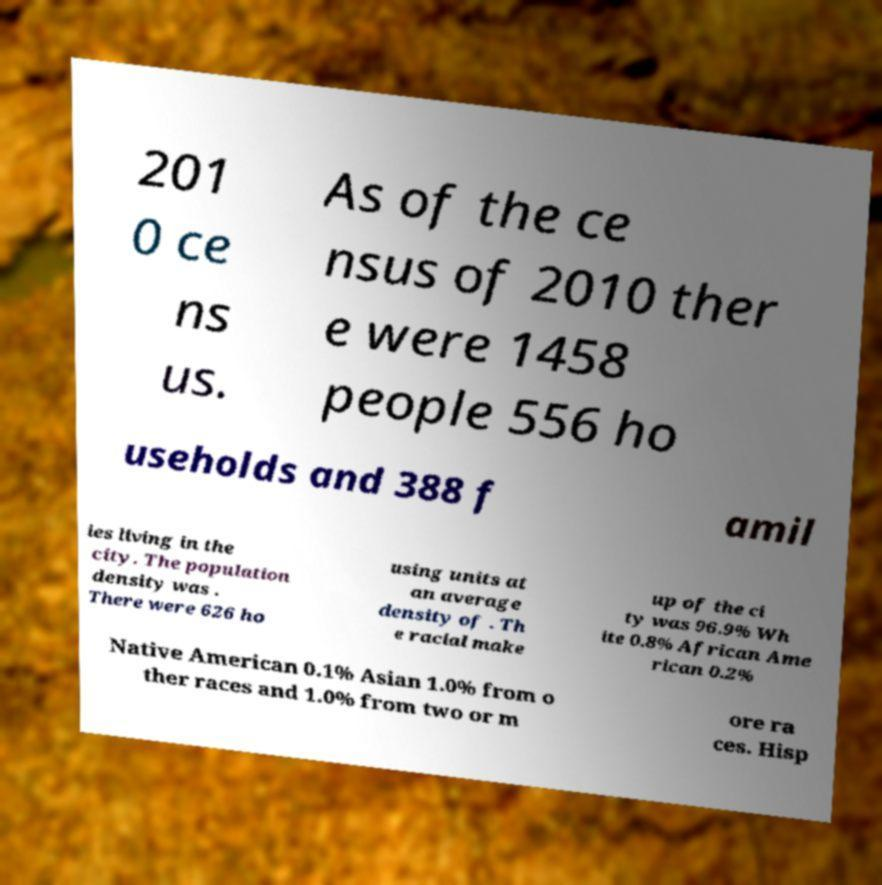I need the written content from this picture converted into text. Can you do that? 201 0 ce ns us. As of the ce nsus of 2010 ther e were 1458 people 556 ho useholds and 388 f amil ies living in the city. The population density was . There were 626 ho using units at an average density of . Th e racial make up of the ci ty was 96.9% Wh ite 0.8% African Ame rican 0.2% Native American 0.1% Asian 1.0% from o ther races and 1.0% from two or m ore ra ces. Hisp 